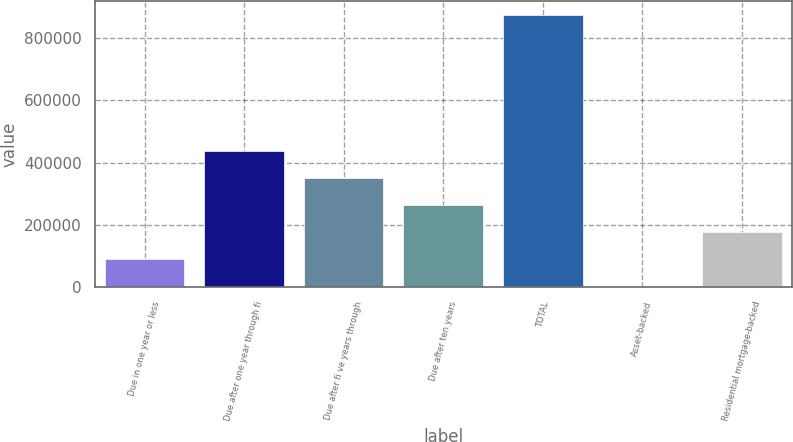<chart> <loc_0><loc_0><loc_500><loc_500><bar_chart><fcel>Due in one year or less<fcel>Due after one year through fi<fcel>Due after fi ve years through<fcel>Due after ten years<fcel>TOTAL<fcel>Asset-backed<fcel>Residential mortgage-backed<nl><fcel>88804<fcel>438628<fcel>351172<fcel>263716<fcel>875908<fcel>1348<fcel>176260<nl></chart> 